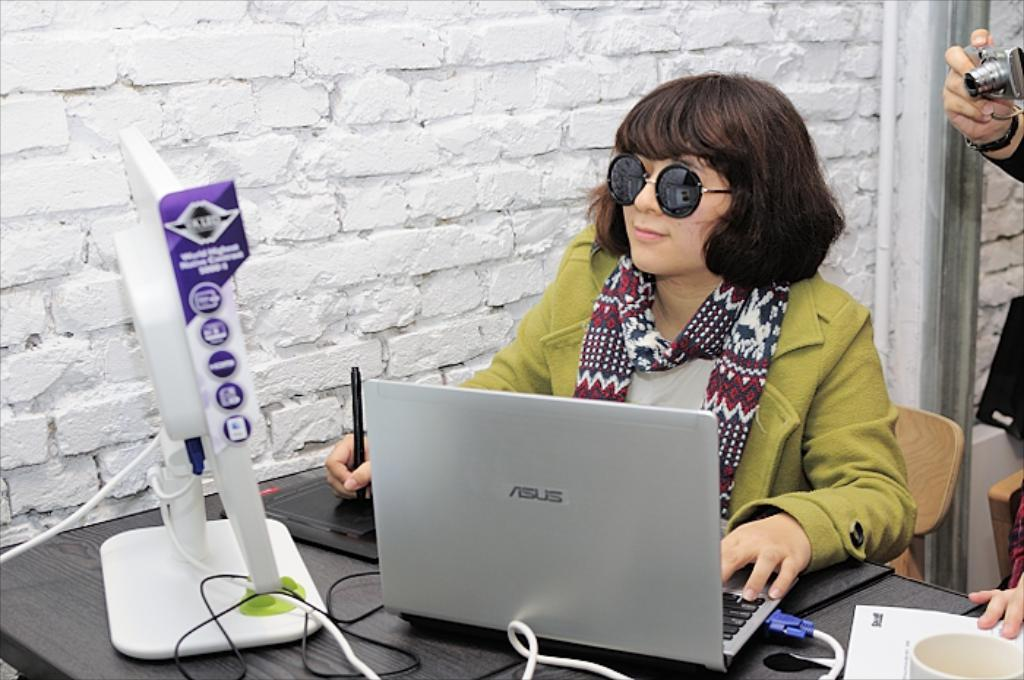What is the person in the image doing? The person is sitting in the image. Where is the person sitting? The person is sitting in front of a table. What object is on the table in the image? There is a laptop on the table. What is the other person in the image holding? The other person is holding a camera in the image. What type of throne is the person sitting on in the image? There is no throne present in the image; the person is sitting in front of a table. What type of skin is visible on the person's hands in the image? The image does not provide enough detail to determine the type of skin on the person's hands. --- Facts: 1. There is a car in the image. 2. The car is parked on the street. 3. There are trees on both sides of the street. 4. The sky is visible in the image. 5. There are clouds in the sky. Absurd Topics: parrot, sand, volcano Conversation: What is the main subject of the image? The main subject of the image is a car. Where is the car located in the image? The car is parked on the street. What can be seen on both sides of the street in the image? There are trees on both sides of the street. What is visible in the sky in the image? The sky is visible in the image, and there are clouds in the sky. Reasoning: Let's think step by step in order to produce the conversation. We start by identifying the main subject in the image, which is the car. Then, we expand the conversation to include the car's location (on the street) and the objects on both sides of the street (trees). Finally, we mention the sky and its visible features (clouds) in the image. Each question is designed to elicit a specific detail about the image that is known from the provided facts. Absurd Question/Answer: What type of parrot can be seen sitting on the car's hood in the image? There is no parrot present in the image; the car is parked on the street with trees on both sides. What type of sand can be seen covering the street in the image? There is no sand present in the image; the street is visible with trees on both sides. 